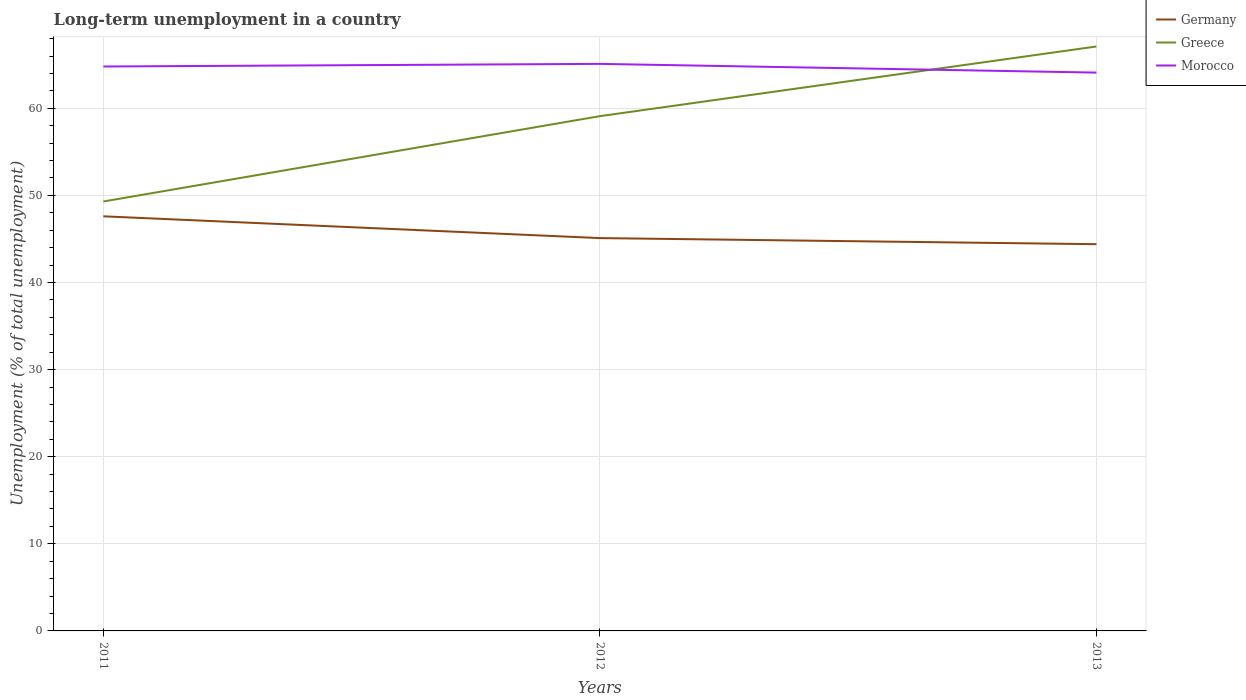Does the line corresponding to Greece intersect with the line corresponding to Morocco?
Make the answer very short. Yes. Across all years, what is the maximum percentage of long-term unemployed population in Greece?
Offer a terse response. 49.3. In which year was the percentage of long-term unemployed population in Germany maximum?
Ensure brevity in your answer.  2013. What is the total percentage of long-term unemployed population in Germany in the graph?
Give a very brief answer. 2.5. What is the difference between the highest and the second highest percentage of long-term unemployed population in Morocco?
Offer a very short reply. 1. Is the percentage of long-term unemployed population in Germany strictly greater than the percentage of long-term unemployed population in Greece over the years?
Make the answer very short. Yes. How many years are there in the graph?
Provide a short and direct response. 3. Does the graph contain any zero values?
Your answer should be very brief. No. Does the graph contain grids?
Provide a succinct answer. Yes. Where does the legend appear in the graph?
Your response must be concise. Top right. How are the legend labels stacked?
Offer a terse response. Vertical. What is the title of the graph?
Keep it short and to the point. Long-term unemployment in a country. Does "Finland" appear as one of the legend labels in the graph?
Make the answer very short. No. What is the label or title of the Y-axis?
Offer a very short reply. Unemployment (% of total unemployment). What is the Unemployment (% of total unemployment) of Germany in 2011?
Offer a terse response. 47.6. What is the Unemployment (% of total unemployment) in Greece in 2011?
Offer a terse response. 49.3. What is the Unemployment (% of total unemployment) in Morocco in 2011?
Keep it short and to the point. 64.8. What is the Unemployment (% of total unemployment) in Germany in 2012?
Give a very brief answer. 45.1. What is the Unemployment (% of total unemployment) in Greece in 2012?
Your response must be concise. 59.1. What is the Unemployment (% of total unemployment) of Morocco in 2012?
Provide a short and direct response. 65.1. What is the Unemployment (% of total unemployment) in Germany in 2013?
Keep it short and to the point. 44.4. What is the Unemployment (% of total unemployment) in Greece in 2013?
Keep it short and to the point. 67.1. What is the Unemployment (% of total unemployment) in Morocco in 2013?
Your answer should be very brief. 64.1. Across all years, what is the maximum Unemployment (% of total unemployment) in Germany?
Ensure brevity in your answer.  47.6. Across all years, what is the maximum Unemployment (% of total unemployment) of Greece?
Keep it short and to the point. 67.1. Across all years, what is the maximum Unemployment (% of total unemployment) of Morocco?
Your answer should be very brief. 65.1. Across all years, what is the minimum Unemployment (% of total unemployment) of Germany?
Provide a succinct answer. 44.4. Across all years, what is the minimum Unemployment (% of total unemployment) of Greece?
Ensure brevity in your answer.  49.3. Across all years, what is the minimum Unemployment (% of total unemployment) in Morocco?
Offer a terse response. 64.1. What is the total Unemployment (% of total unemployment) of Germany in the graph?
Keep it short and to the point. 137.1. What is the total Unemployment (% of total unemployment) of Greece in the graph?
Your answer should be compact. 175.5. What is the total Unemployment (% of total unemployment) of Morocco in the graph?
Give a very brief answer. 194. What is the difference between the Unemployment (% of total unemployment) of Germany in 2011 and that in 2012?
Give a very brief answer. 2.5. What is the difference between the Unemployment (% of total unemployment) in Greece in 2011 and that in 2012?
Give a very brief answer. -9.8. What is the difference between the Unemployment (% of total unemployment) in Germany in 2011 and that in 2013?
Make the answer very short. 3.2. What is the difference between the Unemployment (% of total unemployment) of Greece in 2011 and that in 2013?
Offer a very short reply. -17.8. What is the difference between the Unemployment (% of total unemployment) in Germany in 2012 and that in 2013?
Provide a short and direct response. 0.7. What is the difference between the Unemployment (% of total unemployment) of Morocco in 2012 and that in 2013?
Your response must be concise. 1. What is the difference between the Unemployment (% of total unemployment) in Germany in 2011 and the Unemployment (% of total unemployment) in Greece in 2012?
Make the answer very short. -11.5. What is the difference between the Unemployment (% of total unemployment) in Germany in 2011 and the Unemployment (% of total unemployment) in Morocco in 2012?
Your answer should be compact. -17.5. What is the difference between the Unemployment (% of total unemployment) in Greece in 2011 and the Unemployment (% of total unemployment) in Morocco in 2012?
Ensure brevity in your answer.  -15.8. What is the difference between the Unemployment (% of total unemployment) of Germany in 2011 and the Unemployment (% of total unemployment) of Greece in 2013?
Give a very brief answer. -19.5. What is the difference between the Unemployment (% of total unemployment) of Germany in 2011 and the Unemployment (% of total unemployment) of Morocco in 2013?
Make the answer very short. -16.5. What is the difference between the Unemployment (% of total unemployment) of Greece in 2011 and the Unemployment (% of total unemployment) of Morocco in 2013?
Your answer should be very brief. -14.8. What is the average Unemployment (% of total unemployment) of Germany per year?
Your answer should be compact. 45.7. What is the average Unemployment (% of total unemployment) in Greece per year?
Your answer should be very brief. 58.5. What is the average Unemployment (% of total unemployment) of Morocco per year?
Make the answer very short. 64.67. In the year 2011, what is the difference between the Unemployment (% of total unemployment) of Germany and Unemployment (% of total unemployment) of Morocco?
Ensure brevity in your answer.  -17.2. In the year 2011, what is the difference between the Unemployment (% of total unemployment) in Greece and Unemployment (% of total unemployment) in Morocco?
Make the answer very short. -15.5. In the year 2012, what is the difference between the Unemployment (% of total unemployment) of Germany and Unemployment (% of total unemployment) of Morocco?
Offer a terse response. -20. In the year 2012, what is the difference between the Unemployment (% of total unemployment) in Greece and Unemployment (% of total unemployment) in Morocco?
Make the answer very short. -6. In the year 2013, what is the difference between the Unemployment (% of total unemployment) of Germany and Unemployment (% of total unemployment) of Greece?
Your answer should be very brief. -22.7. In the year 2013, what is the difference between the Unemployment (% of total unemployment) in Germany and Unemployment (% of total unemployment) in Morocco?
Make the answer very short. -19.7. What is the ratio of the Unemployment (% of total unemployment) in Germany in 2011 to that in 2012?
Your response must be concise. 1.06. What is the ratio of the Unemployment (% of total unemployment) in Greece in 2011 to that in 2012?
Your response must be concise. 0.83. What is the ratio of the Unemployment (% of total unemployment) in Germany in 2011 to that in 2013?
Make the answer very short. 1.07. What is the ratio of the Unemployment (% of total unemployment) of Greece in 2011 to that in 2013?
Your response must be concise. 0.73. What is the ratio of the Unemployment (% of total unemployment) in Morocco in 2011 to that in 2013?
Make the answer very short. 1.01. What is the ratio of the Unemployment (% of total unemployment) in Germany in 2012 to that in 2013?
Offer a very short reply. 1.02. What is the ratio of the Unemployment (% of total unemployment) of Greece in 2012 to that in 2013?
Provide a short and direct response. 0.88. What is the ratio of the Unemployment (% of total unemployment) in Morocco in 2012 to that in 2013?
Make the answer very short. 1.02. What is the difference between the highest and the second highest Unemployment (% of total unemployment) in Germany?
Your answer should be very brief. 2.5. What is the difference between the highest and the second highest Unemployment (% of total unemployment) of Greece?
Make the answer very short. 8. What is the difference between the highest and the lowest Unemployment (% of total unemployment) in Germany?
Provide a succinct answer. 3.2. What is the difference between the highest and the lowest Unemployment (% of total unemployment) in Greece?
Offer a very short reply. 17.8. What is the difference between the highest and the lowest Unemployment (% of total unemployment) in Morocco?
Your answer should be compact. 1. 